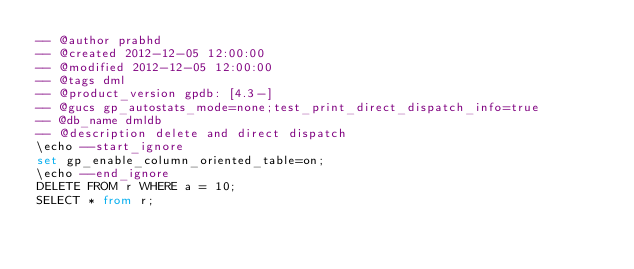Convert code to text. <code><loc_0><loc_0><loc_500><loc_500><_SQL_>-- @author prabhd
-- @created 2012-12-05 12:00:00
-- @modified 2012-12-05 12:00:00
-- @tags dml
-- @product_version gpdb: [4.3-]
-- @gucs gp_autostats_mode=none;test_print_direct_dispatch_info=true
-- @db_name dmldb
-- @description delete and direct dispatch 
\echo --start_ignore
set gp_enable_column_oriented_table=on;
\echo --end_ignore
DELETE FROM r WHERE a = 10;
SELECT * from r;
</code> 